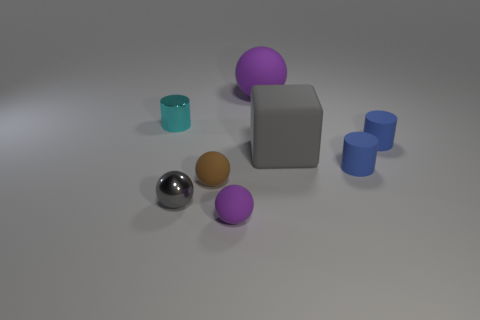Subtract 1 spheres. How many spheres are left? 3 Add 1 small metallic spheres. How many objects exist? 9 Subtract all cylinders. How many objects are left? 5 Add 4 small cyan things. How many small cyan things are left? 5 Add 1 cylinders. How many cylinders exist? 4 Subtract 0 blue cubes. How many objects are left? 8 Subtract all balls. Subtract all small cylinders. How many objects are left? 1 